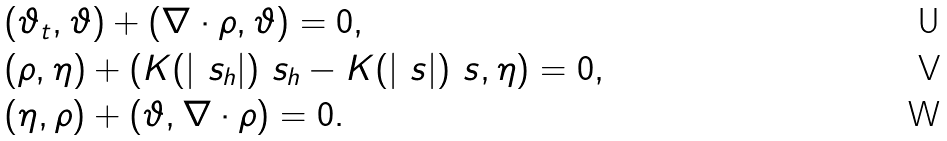Convert formula to latex. <formula><loc_0><loc_0><loc_500><loc_500>& ( \vartheta _ { t } , \vartheta ) + \left ( \nabla \cdot \rho , \vartheta \right ) = 0 , \\ & ( \rho , \eta ) + \left ( K ( | \ s _ { h } | ) \ s _ { h } - K ( | \ s | ) \ s , \eta \right ) = 0 , \\ & ( \eta , \rho ) + ( \vartheta , \nabla \cdot \rho ) = 0 .</formula> 